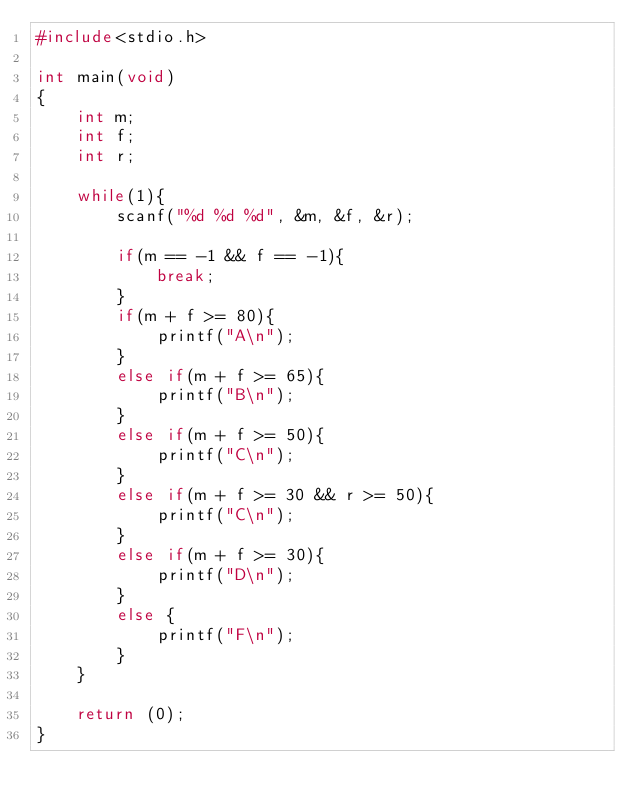Convert code to text. <code><loc_0><loc_0><loc_500><loc_500><_C_>#include<stdio.h>

int main(void)
{
	int m;
	int f;
	int r;
	
	while(1){
		scanf("%d %d %d", &m, &f, &r);
		
		if(m == -1 && f == -1){
			break;
		}
		if(m + f >= 80){
			printf("A\n");
		}
		else if(m + f >= 65){
			printf("B\n");
		}
		else if(m + f >= 50){
			printf("C\n");
		}
		else if(m + f >= 30 && r >= 50){
			printf("C\n");
		}
		else if(m + f >= 30){
			printf("D\n");
		}
		else {
			printf("F\n");
		}
	}
	
	return (0);
}</code> 